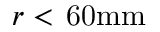<formula> <loc_0><loc_0><loc_500><loc_500>r < \, 6 0 m m</formula> 